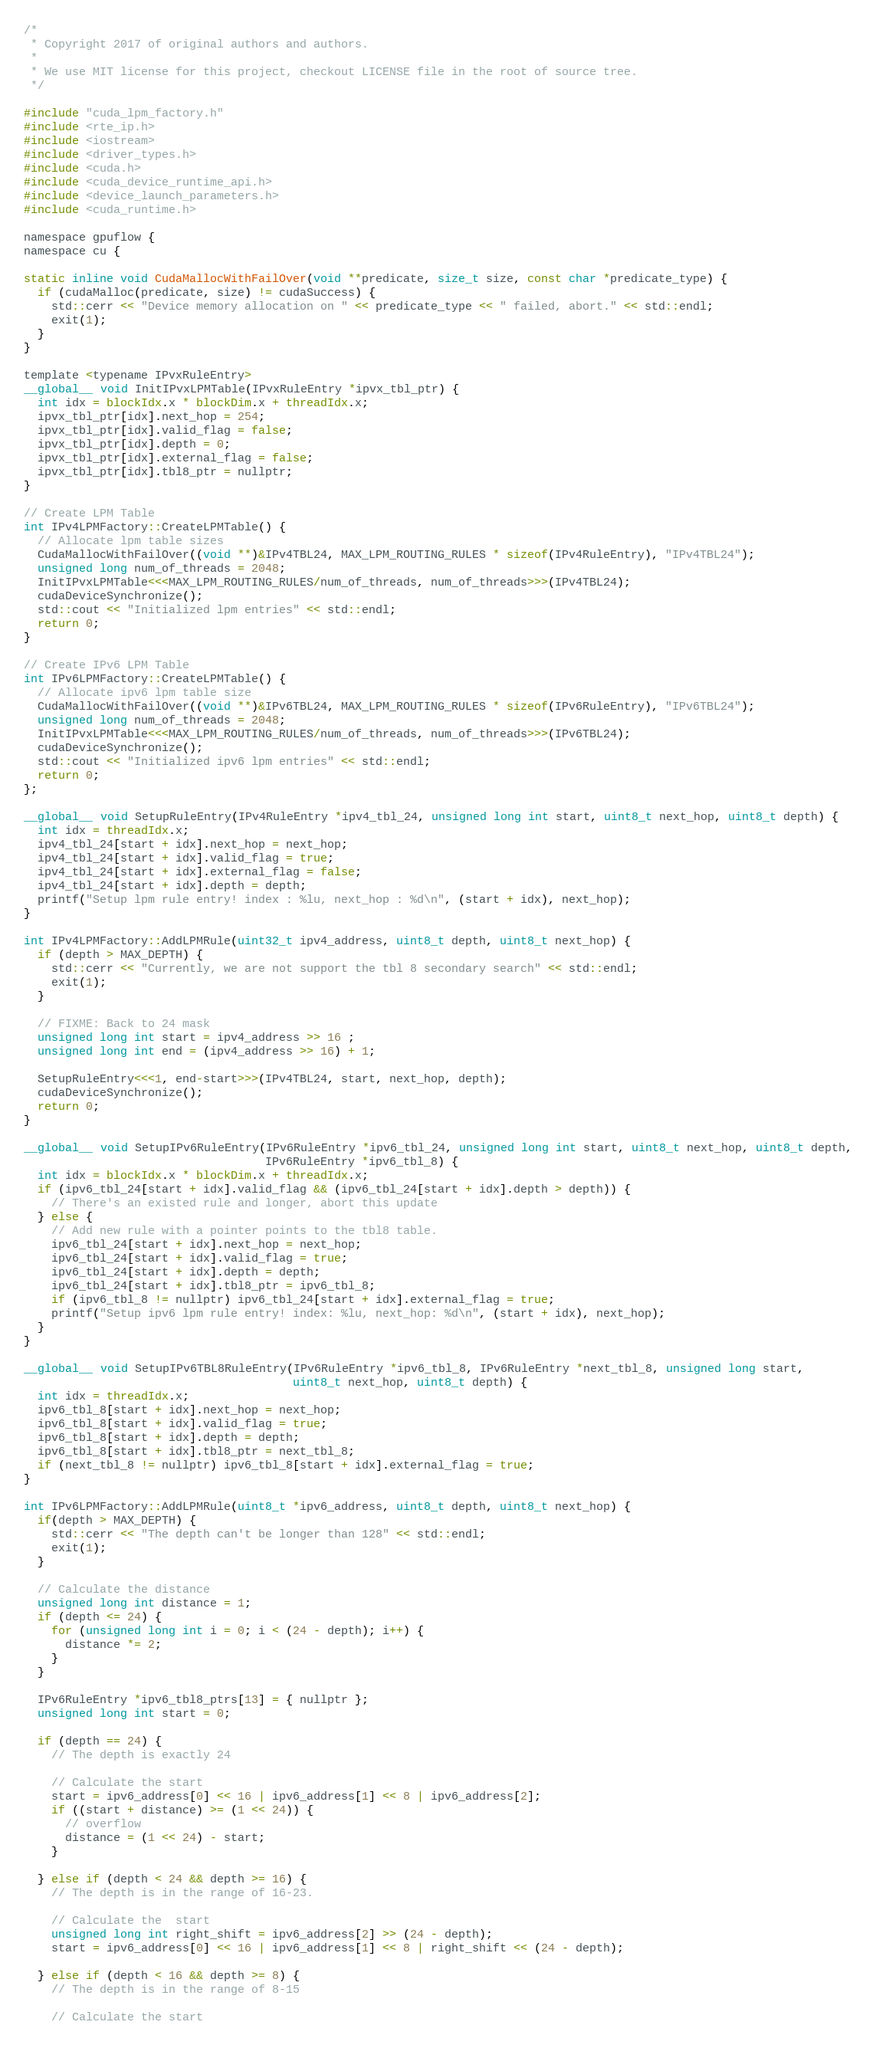Convert code to text. <code><loc_0><loc_0><loc_500><loc_500><_Cuda_>/*
 * Copyright 2017 of original authors and authors.
 *
 * We use MIT license for this project, checkout LICENSE file in the root of source tree.
 */

#include "cuda_lpm_factory.h"
#include <rte_ip.h>
#include <iostream>
#include <driver_types.h>
#include <cuda.h>
#include <cuda_device_runtime_api.h>
#include <device_launch_parameters.h>
#include <cuda_runtime.h>

namespace gpuflow {
namespace cu {

static inline void CudaMallocWithFailOver(void **predicate, size_t size, const char *predicate_type) {
  if (cudaMalloc(predicate, size) != cudaSuccess) {
    std::cerr << "Device memory allocation on " << predicate_type << " failed, abort." << std::endl;
    exit(1);
  }
}

template <typename IPvxRuleEntry>
__global__ void InitIPvxLPMTable(IPvxRuleEntry *ipvx_tbl_ptr) {
  int idx = blockIdx.x * blockDim.x + threadIdx.x;
  ipvx_tbl_ptr[idx].next_hop = 254;
  ipvx_tbl_ptr[idx].valid_flag = false;
  ipvx_tbl_ptr[idx].depth = 0;
  ipvx_tbl_ptr[idx].external_flag = false;
  ipvx_tbl_ptr[idx].tbl8_ptr = nullptr;
}

// Create LPM Table
int IPv4LPMFactory::CreateLPMTable() {
  // Allocate lpm table sizes
  CudaMallocWithFailOver((void **)&IPv4TBL24, MAX_LPM_ROUTING_RULES * sizeof(IPv4RuleEntry), "IPv4TBL24");
  unsigned long num_of_threads = 2048;
  InitIPvxLPMTable<<<MAX_LPM_ROUTING_RULES/num_of_threads, num_of_threads>>>(IPv4TBL24);
  cudaDeviceSynchronize();
  std::cout << "Initialized lpm entries" << std::endl;
  return 0;
}

// Create IPv6 LPM Table
int IPv6LPMFactory::CreateLPMTable() {
  // Allocate ipv6 lpm table size
  CudaMallocWithFailOver((void **)&IPv6TBL24, MAX_LPM_ROUTING_RULES * sizeof(IPv6RuleEntry), "IPv6TBL24");
  unsigned long num_of_threads = 2048;
  InitIPvxLPMTable<<<MAX_LPM_ROUTING_RULES/num_of_threads, num_of_threads>>>(IPv6TBL24);
  cudaDeviceSynchronize();
  std::cout << "Initialized ipv6 lpm entries" << std::endl;
  return 0;
};

__global__ void SetupRuleEntry(IPv4RuleEntry *ipv4_tbl_24, unsigned long int start, uint8_t next_hop, uint8_t depth) {
  int idx = threadIdx.x;
  ipv4_tbl_24[start + idx].next_hop = next_hop;
  ipv4_tbl_24[start + idx].valid_flag = true;
  ipv4_tbl_24[start + idx].external_flag = false;
  ipv4_tbl_24[start + idx].depth = depth;
  printf("Setup lpm rule entry! index : %lu, next_hop : %d\n", (start + idx), next_hop);
}

int IPv4LPMFactory::AddLPMRule(uint32_t ipv4_address, uint8_t depth, uint8_t next_hop) {
  if (depth > MAX_DEPTH) {
    std::cerr << "Currently, we are not support the tbl 8 secondary search" << std::endl;
    exit(1);
  }

  // FIXME: Back to 24 mask
  unsigned long int start = ipv4_address >> 16 ;
  unsigned long int end = (ipv4_address >> 16) + 1;

  SetupRuleEntry<<<1, end-start>>>(IPv4TBL24, start, next_hop, depth);
  cudaDeviceSynchronize();
  return 0;
}

__global__ void SetupIPv6RuleEntry(IPv6RuleEntry *ipv6_tbl_24, unsigned long int start, uint8_t next_hop, uint8_t depth,
                                   IPv6RuleEntry *ipv6_tbl_8) {
  int idx = blockIdx.x * blockDim.x + threadIdx.x;
  if (ipv6_tbl_24[start + idx].valid_flag && (ipv6_tbl_24[start + idx].depth > depth)) {
    // There's an existed rule and longer, abort this update
  } else {
    // Add new rule with a pointer points to the tbl8 table.
    ipv6_tbl_24[start + idx].next_hop = next_hop;
    ipv6_tbl_24[start + idx].valid_flag = true;
    ipv6_tbl_24[start + idx].depth = depth;
    ipv6_tbl_24[start + idx].tbl8_ptr = ipv6_tbl_8;
    if (ipv6_tbl_8 != nullptr) ipv6_tbl_24[start + idx].external_flag = true;
    printf("Setup ipv6 lpm rule entry! index: %lu, next_hop: %d\n", (start + idx), next_hop);
  }
}

__global__ void SetupIPv6TBL8RuleEntry(IPv6RuleEntry *ipv6_tbl_8, IPv6RuleEntry *next_tbl_8, unsigned long start,
                                       uint8_t next_hop, uint8_t depth) {
  int idx = threadIdx.x;
  ipv6_tbl_8[start + idx].next_hop = next_hop;
  ipv6_tbl_8[start + idx].valid_flag = true;
  ipv6_tbl_8[start + idx].depth = depth;
  ipv6_tbl_8[start + idx].tbl8_ptr = next_tbl_8;
  if (next_tbl_8 != nullptr) ipv6_tbl_8[start + idx].external_flag = true;
}

int IPv6LPMFactory::AddLPMRule(uint8_t *ipv6_address, uint8_t depth, uint8_t next_hop) {
  if(depth > MAX_DEPTH) {
    std::cerr << "The depth can't be longer than 128" << std::endl;
    exit(1);
  }

  // Calculate the distance
  unsigned long int distance = 1;
  if (depth <= 24) {
    for (unsigned long int i = 0; i < (24 - depth); i++) {
      distance *= 2;
    }
  }

  IPv6RuleEntry *ipv6_tbl8_ptrs[13] = { nullptr };
  unsigned long int start = 0;

  if (depth == 24) {
    // The depth is exactly 24

    // Calculate the start
    start = ipv6_address[0] << 16 | ipv6_address[1] << 8 | ipv6_address[2];
    if ((start + distance) >= (1 << 24)) {
      // overflow
      distance = (1 << 24) - start;
    }

  } else if (depth < 24 && depth >= 16) {
    // The depth is in the range of 16-23.

    // Calculate the  start
    unsigned long int right_shift = ipv6_address[2] >> (24 - depth);
    start = ipv6_address[0] << 16 | ipv6_address[1] << 8 | right_shift << (24 - depth);

  } else if (depth < 16 && depth >= 8) {
    // The depth is in the range of 8-15

    // Calculate the start</code> 